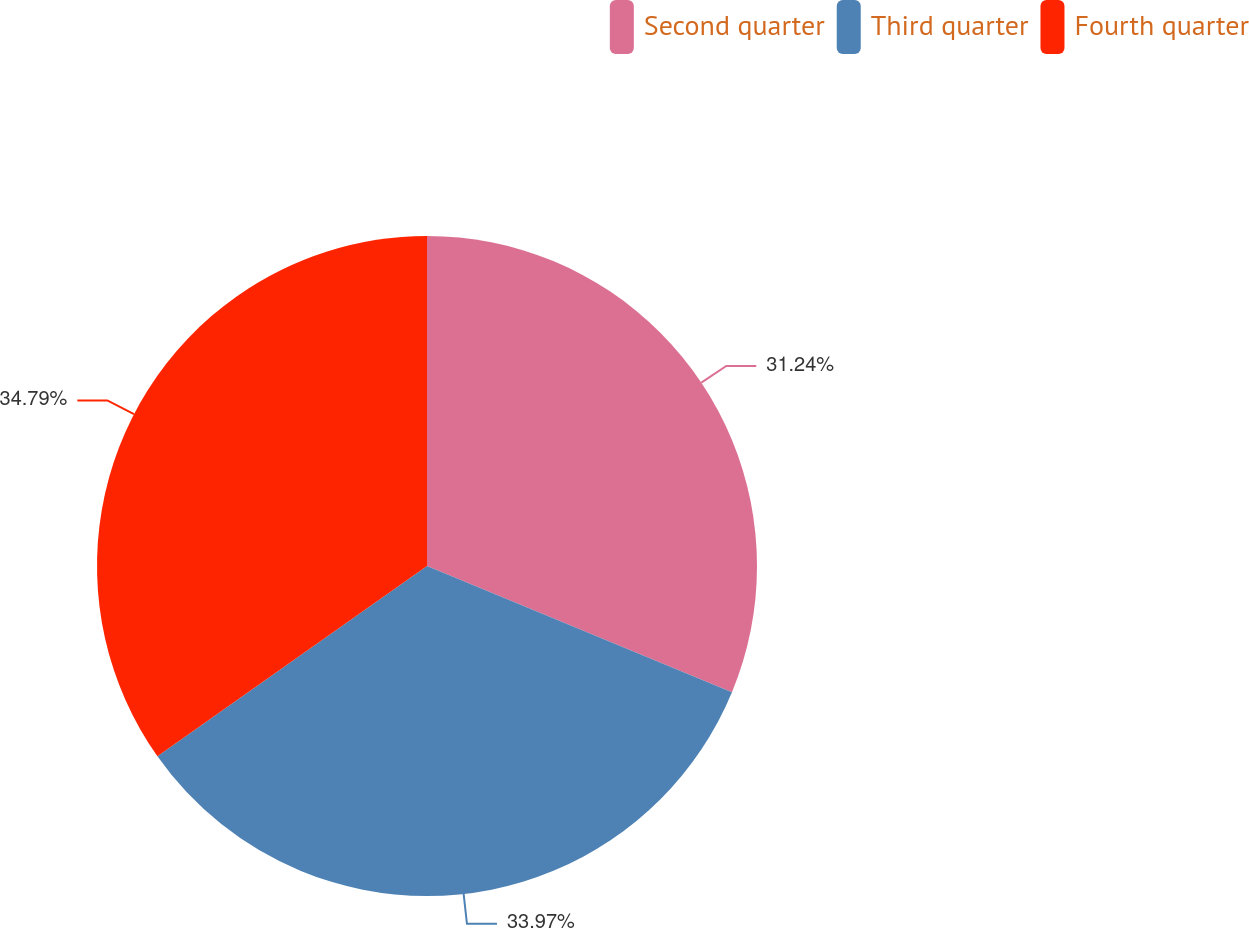Convert chart. <chart><loc_0><loc_0><loc_500><loc_500><pie_chart><fcel>Second quarter<fcel>Third quarter<fcel>Fourth quarter<nl><fcel>31.24%<fcel>33.97%<fcel>34.78%<nl></chart> 